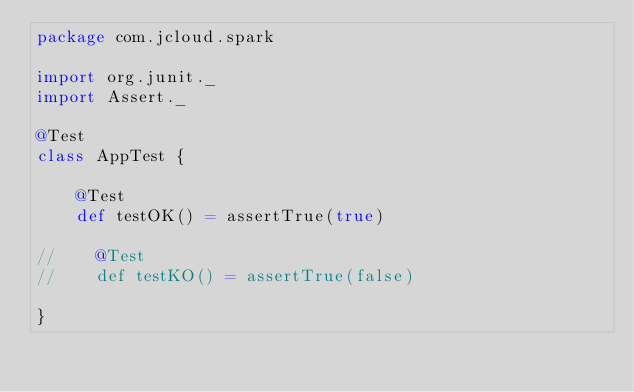<code> <loc_0><loc_0><loc_500><loc_500><_Scala_>package com.jcloud.spark

import org.junit._
import Assert._

@Test
class AppTest {

    @Test
    def testOK() = assertTrue(true)

//    @Test
//    def testKO() = assertTrue(false)

}


</code> 